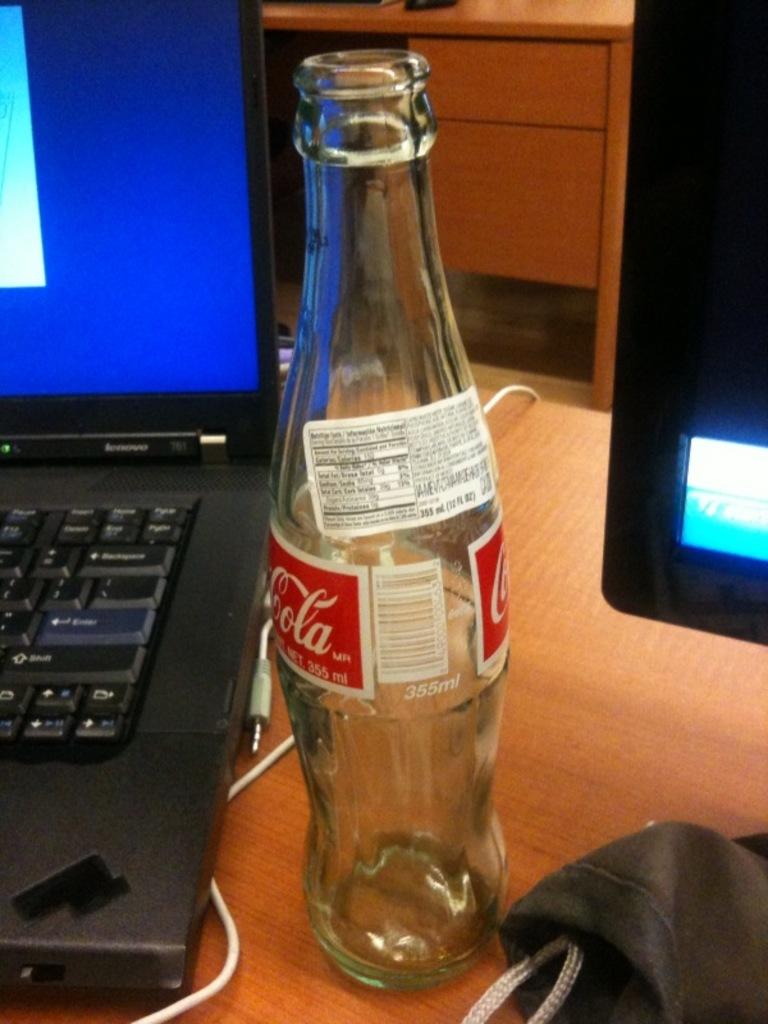What is the brand of laptop?
Offer a very short reply. Lenovo. 